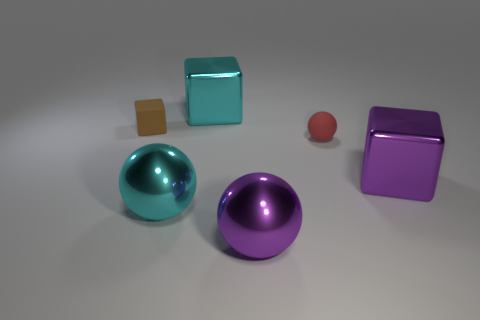What is the size of the purple sphere that is made of the same material as the purple cube?
Provide a succinct answer. Large. How big is the cyan object right of the cyan metallic thing in front of the object that is behind the small brown matte thing?
Your response must be concise. Large. The large thing that is in front of the big cyan ball is what color?
Your answer should be compact. Purple. Is the number of large metal balls left of the matte sphere greater than the number of gray shiny cylinders?
Your answer should be compact. Yes. Does the purple thing that is to the right of the tiny red object have the same shape as the brown thing?
Offer a terse response. Yes. How many cyan objects are large things or shiny blocks?
Provide a succinct answer. 2. Are there more rubber blocks than brown metallic cylinders?
Your answer should be compact. Yes. There is another metal block that is the same size as the purple metallic block; what is its color?
Give a very brief answer. Cyan. What number of balls are red rubber things or large purple metal objects?
Your answer should be very brief. 2. Is the shape of the small brown rubber thing the same as the purple shiny object that is on the right side of the tiny rubber sphere?
Make the answer very short. Yes. 